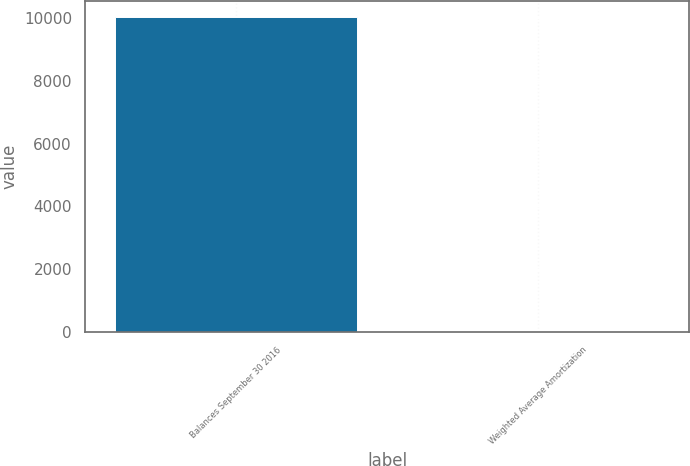<chart> <loc_0><loc_0><loc_500><loc_500><bar_chart><fcel>Balances September 30 2016<fcel>Weighted Average Amortization<nl><fcel>10027<fcel>25<nl></chart> 